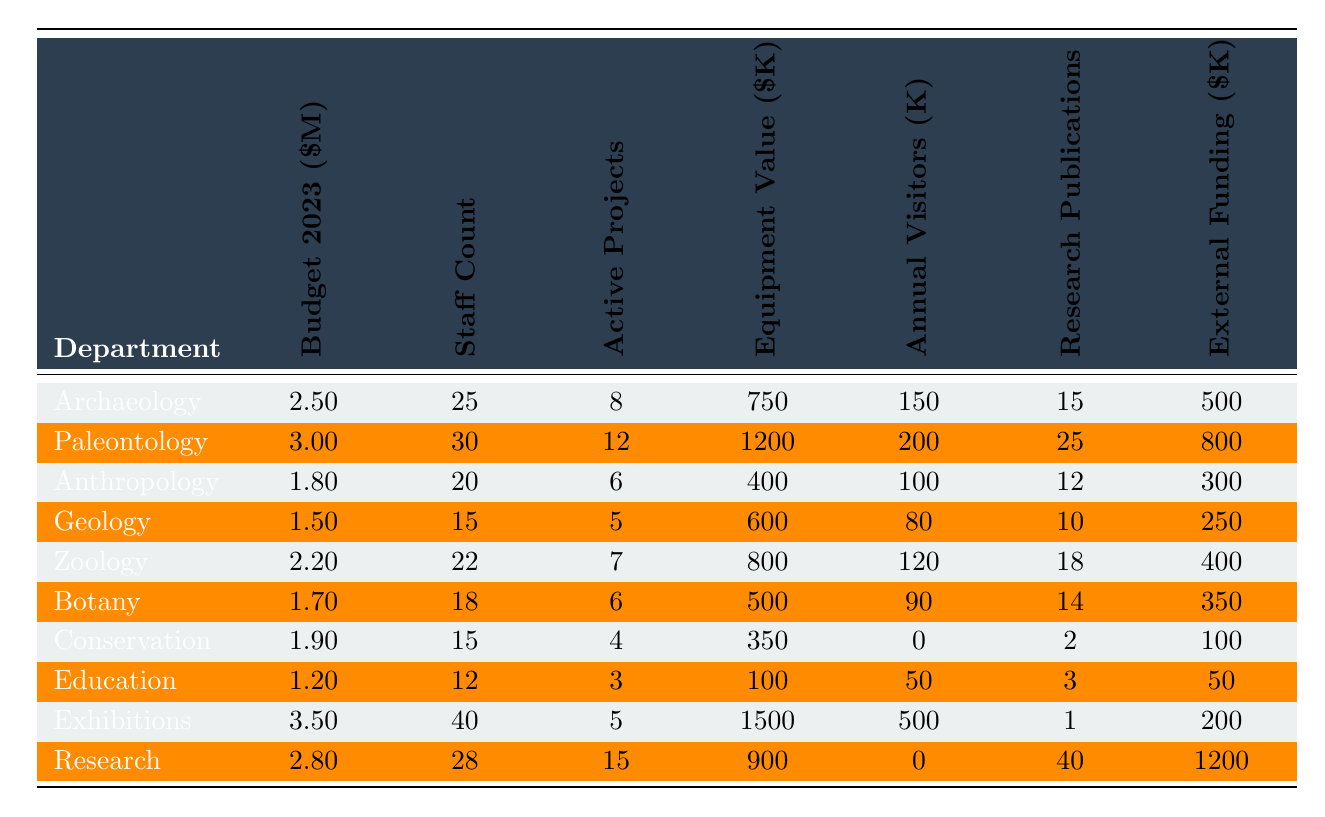What is the budget allocation for the Paleontology department in 2023? The table shows that the budget allocation for the Paleontology department is directly listed in the second column next to its name. It states that the allocation is 3 million dollars.
Answer: 3 million dollars Which department has the highest staff count? In the staff count column, the highest number is 40, which corresponds to the Exhibitions department, as it is the only department with that count.
Answer: Exhibitions What is the total budget allocation for the Zoology and Botany departments? The budget allocation for Zoology is 2.2 million dollars and for Botany, it is 1.7 million dollars. Adding these together gives 2.2 + 1.7 = 3.9 million dollars.
Answer: 3.9 million dollars How many active projects does the Research department have? Referring to the active projects column, the Research department has 15 active projects listed beside it.
Answer: 15 Is the Conservation department's equipment value greater than its annual visitors? The equipment value for Conservation is 350,000 dollars (or 0 when considering thousands), and the annual visitors are 0. Therefore, since 350,000 > 0, the statement is true.
Answer: Yes Which department has the least number of annual visitors? In the annual visitors column, the Conservation department has 0 visitors, which is the lowest compared to the other departments listed.
Answer: Conservation What is the average budget allocation for all departments? To find the average, sum up all the budget allocations: (2.5 + 3 + 1.8 + 1.5 + 2.2 + 1.7 + 1.9 + 1.2 + 3.5 + 2.8) = 20.1 million dollars. Dividing by the number of departments (10) gives an average of 20.1/10 = 2.01 million dollars.
Answer: 2.01 million dollars How many more research publications does the Research department have than the Anthropology department? The Research department has 40 publications, and the Anthropology department has 12. The difference is 40 - 12 = 28 publications.
Answer: 28 publications Which department received the least external funding? The external funding for Conservation is 100,000 dollars, which is less than the funding for all other departments.
Answer: Conservation Find the department with the highest equipment value and state that value. The highest equipment value is found in the Exhibitions department, which has an equipment value of 1,500,000 dollars.
Answer: 1,500,000 dollars 